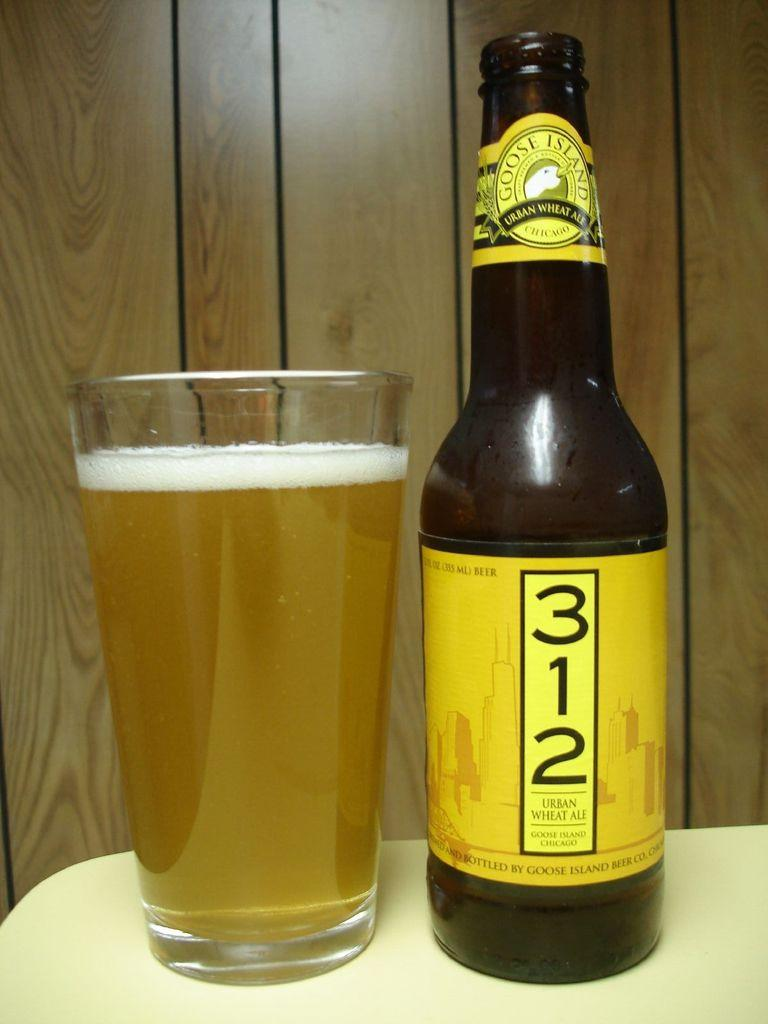<image>
Share a concise interpretation of the image provided. A bottle of 312 beer sitting next to a pint glass filled with beer. 